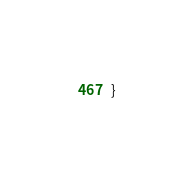<code> <loc_0><loc_0><loc_500><loc_500><_Java_>}
</code> 